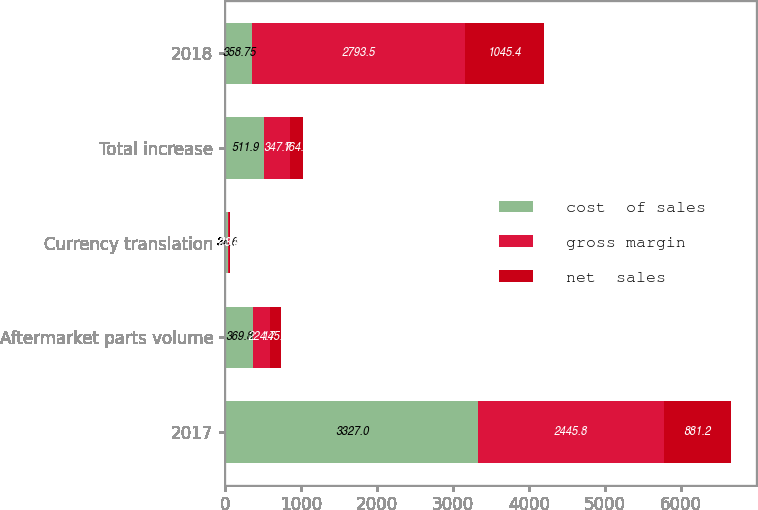<chart> <loc_0><loc_0><loc_500><loc_500><stacked_bar_chart><ecel><fcel>2017<fcel>Aftermarket parts volume<fcel>Currency translation<fcel>Total increase<fcel>2018<nl><fcel>cost  of sales<fcel>3327<fcel>369.8<fcel>34.6<fcel>511.9<fcel>358.75<nl><fcel>gross margin<fcel>2445.8<fcel>224.7<fcel>21.4<fcel>347.7<fcel>2793.5<nl><fcel>net  sales<fcel>881.2<fcel>145.1<fcel>13.2<fcel>164.2<fcel>1045.4<nl></chart> 